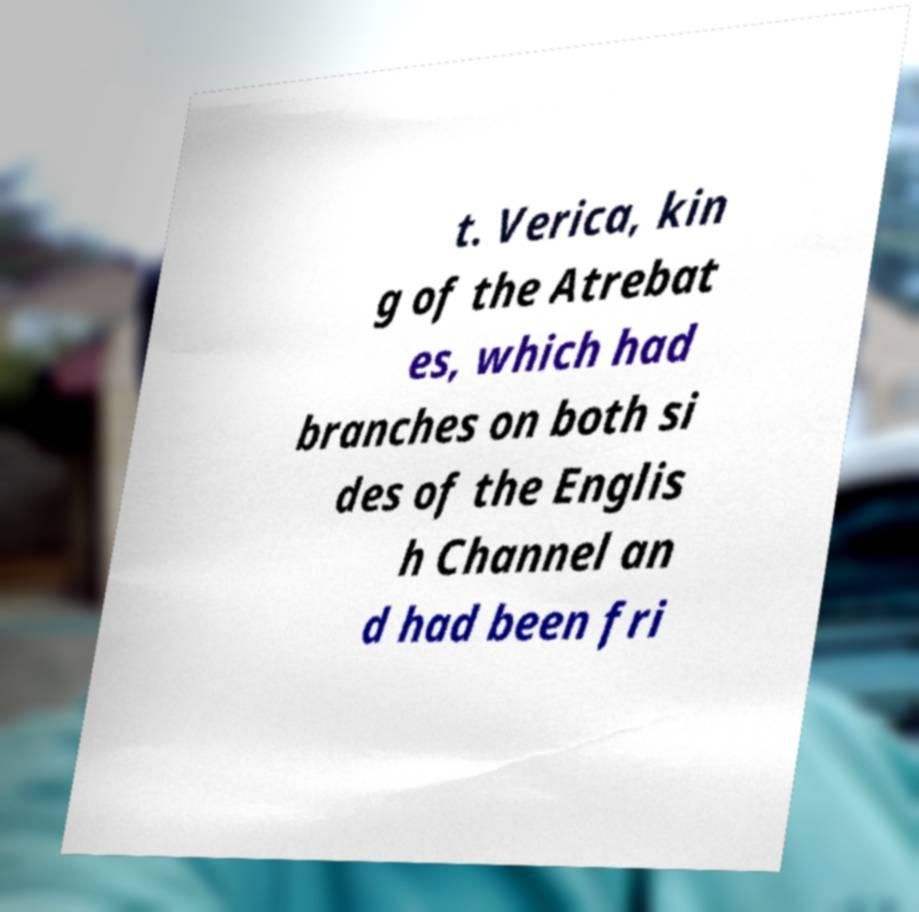Please identify and transcribe the text found in this image. t. Verica, kin g of the Atrebat es, which had branches on both si des of the Englis h Channel an d had been fri 